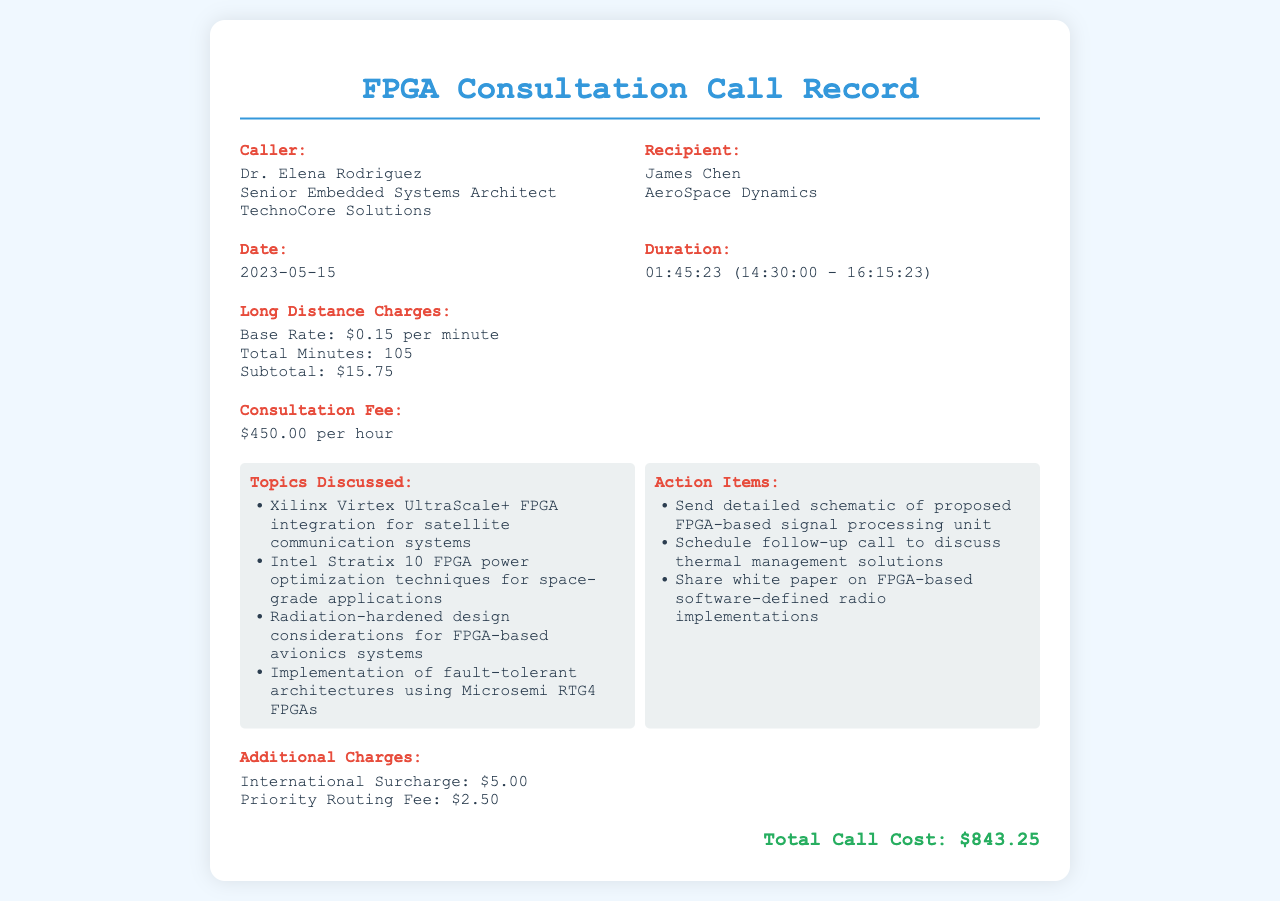What is the caller's name? The caller's name is stated clearly in the header section of the document as Dr. Elena Rodriguez.
Answer: Dr. Elena Rodriguez What is the recipient's organization? The recipient's organization is AeroSpace Dynamics, mentioned right below the recipient's name.
Answer: AeroSpace Dynamics What is the date of the call? The date is indicated in the specified section of the document as 2023-05-15.
Answer: 2023-05-15 How long did the call last? The duration of the call is provided in the information section and is 01:45:23.
Answer: 01:45:23 What was the base rate for long-distance charges? The base rate for long-distance charges is given as $0.15 per minute.
Answer: $0.15 per minute What is the total call cost? The total call cost is summarized at the end of the document as $843.25.
Answer: $843.25 How many topics were discussed? The number of topics can be counted from the list under “Topics Discussed” in the document, there are four items.
Answer: 4 What was the international surcharge? The international surcharge is specified in the additional charges section as $5.00.
Answer: $5.00 What action item involved a follow-up call? An action item mentions to "Schedule follow-up call to discuss thermal management solutions."
Answer: Schedule follow-up call to discuss thermal management solutions 